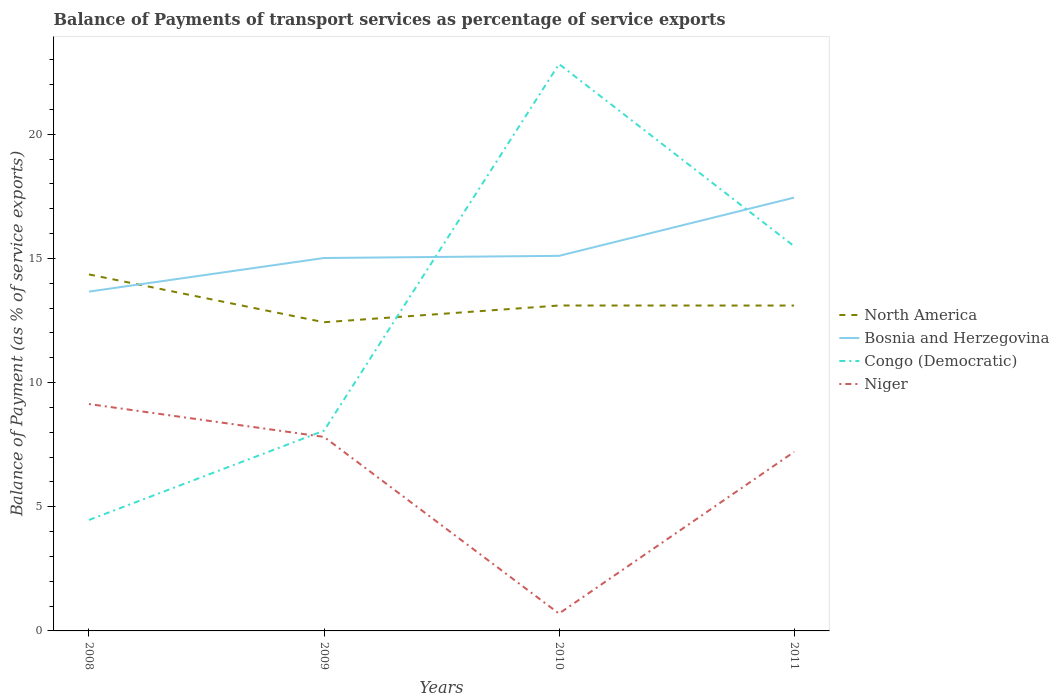How many different coloured lines are there?
Offer a terse response. 4. Does the line corresponding to Bosnia and Herzegovina intersect with the line corresponding to North America?
Your response must be concise. Yes. Is the number of lines equal to the number of legend labels?
Keep it short and to the point. Yes. Across all years, what is the maximum balance of payments of transport services in North America?
Your response must be concise. 12.43. In which year was the balance of payments of transport services in Congo (Democratic) maximum?
Offer a very short reply. 2008. What is the total balance of payments of transport services in North America in the graph?
Make the answer very short. -0.67. What is the difference between the highest and the second highest balance of payments of transport services in Congo (Democratic)?
Give a very brief answer. 18.36. What is the difference between the highest and the lowest balance of payments of transport services in North America?
Give a very brief answer. 1. Is the balance of payments of transport services in Bosnia and Herzegovina strictly greater than the balance of payments of transport services in North America over the years?
Give a very brief answer. No. Does the graph contain any zero values?
Provide a short and direct response. No. How many legend labels are there?
Keep it short and to the point. 4. How are the legend labels stacked?
Offer a very short reply. Vertical. What is the title of the graph?
Offer a terse response. Balance of Payments of transport services as percentage of service exports. Does "Comoros" appear as one of the legend labels in the graph?
Your response must be concise. No. What is the label or title of the X-axis?
Make the answer very short. Years. What is the label or title of the Y-axis?
Keep it short and to the point. Balance of Payment (as % of service exports). What is the Balance of Payment (as % of service exports) of North America in 2008?
Offer a terse response. 14.35. What is the Balance of Payment (as % of service exports) of Bosnia and Herzegovina in 2008?
Offer a terse response. 13.66. What is the Balance of Payment (as % of service exports) in Congo (Democratic) in 2008?
Provide a succinct answer. 4.47. What is the Balance of Payment (as % of service exports) of Niger in 2008?
Your response must be concise. 9.14. What is the Balance of Payment (as % of service exports) of North America in 2009?
Ensure brevity in your answer.  12.43. What is the Balance of Payment (as % of service exports) of Bosnia and Herzegovina in 2009?
Give a very brief answer. 15.02. What is the Balance of Payment (as % of service exports) of Congo (Democratic) in 2009?
Provide a short and direct response. 8.06. What is the Balance of Payment (as % of service exports) in Niger in 2009?
Ensure brevity in your answer.  7.81. What is the Balance of Payment (as % of service exports) in North America in 2010?
Your response must be concise. 13.1. What is the Balance of Payment (as % of service exports) of Bosnia and Herzegovina in 2010?
Your response must be concise. 15.1. What is the Balance of Payment (as % of service exports) of Congo (Democratic) in 2010?
Your answer should be compact. 22.83. What is the Balance of Payment (as % of service exports) of Niger in 2010?
Keep it short and to the point. 0.7. What is the Balance of Payment (as % of service exports) in North America in 2011?
Your response must be concise. 13.1. What is the Balance of Payment (as % of service exports) in Bosnia and Herzegovina in 2011?
Give a very brief answer. 17.45. What is the Balance of Payment (as % of service exports) in Congo (Democratic) in 2011?
Your answer should be compact. 15.49. What is the Balance of Payment (as % of service exports) of Niger in 2011?
Your response must be concise. 7.21. Across all years, what is the maximum Balance of Payment (as % of service exports) of North America?
Your answer should be very brief. 14.35. Across all years, what is the maximum Balance of Payment (as % of service exports) of Bosnia and Herzegovina?
Make the answer very short. 17.45. Across all years, what is the maximum Balance of Payment (as % of service exports) in Congo (Democratic)?
Offer a very short reply. 22.83. Across all years, what is the maximum Balance of Payment (as % of service exports) of Niger?
Your answer should be compact. 9.14. Across all years, what is the minimum Balance of Payment (as % of service exports) in North America?
Offer a terse response. 12.43. Across all years, what is the minimum Balance of Payment (as % of service exports) in Bosnia and Herzegovina?
Give a very brief answer. 13.66. Across all years, what is the minimum Balance of Payment (as % of service exports) of Congo (Democratic)?
Offer a terse response. 4.47. Across all years, what is the minimum Balance of Payment (as % of service exports) of Niger?
Offer a very short reply. 0.7. What is the total Balance of Payment (as % of service exports) in North America in the graph?
Your answer should be compact. 52.99. What is the total Balance of Payment (as % of service exports) in Bosnia and Herzegovina in the graph?
Keep it short and to the point. 61.23. What is the total Balance of Payment (as % of service exports) in Congo (Democratic) in the graph?
Ensure brevity in your answer.  50.85. What is the total Balance of Payment (as % of service exports) in Niger in the graph?
Your answer should be compact. 24.85. What is the difference between the Balance of Payment (as % of service exports) in North America in 2008 and that in 2009?
Offer a very short reply. 1.93. What is the difference between the Balance of Payment (as % of service exports) of Bosnia and Herzegovina in 2008 and that in 2009?
Your answer should be compact. -1.35. What is the difference between the Balance of Payment (as % of service exports) in Congo (Democratic) in 2008 and that in 2009?
Your answer should be very brief. -3.6. What is the difference between the Balance of Payment (as % of service exports) of Niger in 2008 and that in 2009?
Keep it short and to the point. 1.32. What is the difference between the Balance of Payment (as % of service exports) of North America in 2008 and that in 2010?
Offer a terse response. 1.25. What is the difference between the Balance of Payment (as % of service exports) of Bosnia and Herzegovina in 2008 and that in 2010?
Offer a terse response. -1.44. What is the difference between the Balance of Payment (as % of service exports) of Congo (Democratic) in 2008 and that in 2010?
Keep it short and to the point. -18.36. What is the difference between the Balance of Payment (as % of service exports) in Niger in 2008 and that in 2010?
Offer a very short reply. 8.44. What is the difference between the Balance of Payment (as % of service exports) of North America in 2008 and that in 2011?
Provide a short and direct response. 1.25. What is the difference between the Balance of Payment (as % of service exports) of Bosnia and Herzegovina in 2008 and that in 2011?
Offer a terse response. -3.78. What is the difference between the Balance of Payment (as % of service exports) in Congo (Democratic) in 2008 and that in 2011?
Offer a terse response. -11.02. What is the difference between the Balance of Payment (as % of service exports) of Niger in 2008 and that in 2011?
Keep it short and to the point. 1.93. What is the difference between the Balance of Payment (as % of service exports) in North America in 2009 and that in 2010?
Give a very brief answer. -0.67. What is the difference between the Balance of Payment (as % of service exports) in Bosnia and Herzegovina in 2009 and that in 2010?
Provide a succinct answer. -0.09. What is the difference between the Balance of Payment (as % of service exports) in Congo (Democratic) in 2009 and that in 2010?
Make the answer very short. -14.76. What is the difference between the Balance of Payment (as % of service exports) in Niger in 2009 and that in 2010?
Offer a very short reply. 7.11. What is the difference between the Balance of Payment (as % of service exports) of North America in 2009 and that in 2011?
Your answer should be very brief. -0.67. What is the difference between the Balance of Payment (as % of service exports) in Bosnia and Herzegovina in 2009 and that in 2011?
Offer a terse response. -2.43. What is the difference between the Balance of Payment (as % of service exports) of Congo (Democratic) in 2009 and that in 2011?
Keep it short and to the point. -7.43. What is the difference between the Balance of Payment (as % of service exports) of Niger in 2009 and that in 2011?
Your answer should be compact. 0.61. What is the difference between the Balance of Payment (as % of service exports) in North America in 2010 and that in 2011?
Offer a terse response. 0. What is the difference between the Balance of Payment (as % of service exports) of Bosnia and Herzegovina in 2010 and that in 2011?
Ensure brevity in your answer.  -2.34. What is the difference between the Balance of Payment (as % of service exports) in Congo (Democratic) in 2010 and that in 2011?
Your response must be concise. 7.33. What is the difference between the Balance of Payment (as % of service exports) in Niger in 2010 and that in 2011?
Give a very brief answer. -6.51. What is the difference between the Balance of Payment (as % of service exports) of North America in 2008 and the Balance of Payment (as % of service exports) of Bosnia and Herzegovina in 2009?
Make the answer very short. -0.66. What is the difference between the Balance of Payment (as % of service exports) of North America in 2008 and the Balance of Payment (as % of service exports) of Congo (Democratic) in 2009?
Your response must be concise. 6.29. What is the difference between the Balance of Payment (as % of service exports) of North America in 2008 and the Balance of Payment (as % of service exports) of Niger in 2009?
Offer a very short reply. 6.54. What is the difference between the Balance of Payment (as % of service exports) in Bosnia and Herzegovina in 2008 and the Balance of Payment (as % of service exports) in Congo (Democratic) in 2009?
Give a very brief answer. 5.6. What is the difference between the Balance of Payment (as % of service exports) of Bosnia and Herzegovina in 2008 and the Balance of Payment (as % of service exports) of Niger in 2009?
Offer a very short reply. 5.85. What is the difference between the Balance of Payment (as % of service exports) of Congo (Democratic) in 2008 and the Balance of Payment (as % of service exports) of Niger in 2009?
Offer a terse response. -3.34. What is the difference between the Balance of Payment (as % of service exports) of North America in 2008 and the Balance of Payment (as % of service exports) of Bosnia and Herzegovina in 2010?
Offer a very short reply. -0.75. What is the difference between the Balance of Payment (as % of service exports) in North America in 2008 and the Balance of Payment (as % of service exports) in Congo (Democratic) in 2010?
Make the answer very short. -8.47. What is the difference between the Balance of Payment (as % of service exports) in North America in 2008 and the Balance of Payment (as % of service exports) in Niger in 2010?
Your response must be concise. 13.66. What is the difference between the Balance of Payment (as % of service exports) in Bosnia and Herzegovina in 2008 and the Balance of Payment (as % of service exports) in Congo (Democratic) in 2010?
Offer a terse response. -9.16. What is the difference between the Balance of Payment (as % of service exports) in Bosnia and Herzegovina in 2008 and the Balance of Payment (as % of service exports) in Niger in 2010?
Make the answer very short. 12.96. What is the difference between the Balance of Payment (as % of service exports) of Congo (Democratic) in 2008 and the Balance of Payment (as % of service exports) of Niger in 2010?
Your answer should be very brief. 3.77. What is the difference between the Balance of Payment (as % of service exports) of North America in 2008 and the Balance of Payment (as % of service exports) of Bosnia and Herzegovina in 2011?
Provide a short and direct response. -3.09. What is the difference between the Balance of Payment (as % of service exports) in North America in 2008 and the Balance of Payment (as % of service exports) in Congo (Democratic) in 2011?
Offer a terse response. -1.14. What is the difference between the Balance of Payment (as % of service exports) of North America in 2008 and the Balance of Payment (as % of service exports) of Niger in 2011?
Offer a very short reply. 7.15. What is the difference between the Balance of Payment (as % of service exports) in Bosnia and Herzegovina in 2008 and the Balance of Payment (as % of service exports) in Congo (Democratic) in 2011?
Give a very brief answer. -1.83. What is the difference between the Balance of Payment (as % of service exports) in Bosnia and Herzegovina in 2008 and the Balance of Payment (as % of service exports) in Niger in 2011?
Offer a terse response. 6.46. What is the difference between the Balance of Payment (as % of service exports) in Congo (Democratic) in 2008 and the Balance of Payment (as % of service exports) in Niger in 2011?
Offer a terse response. -2.74. What is the difference between the Balance of Payment (as % of service exports) in North America in 2009 and the Balance of Payment (as % of service exports) in Bosnia and Herzegovina in 2010?
Provide a succinct answer. -2.67. What is the difference between the Balance of Payment (as % of service exports) of North America in 2009 and the Balance of Payment (as % of service exports) of Congo (Democratic) in 2010?
Offer a very short reply. -10.4. What is the difference between the Balance of Payment (as % of service exports) of North America in 2009 and the Balance of Payment (as % of service exports) of Niger in 2010?
Ensure brevity in your answer.  11.73. What is the difference between the Balance of Payment (as % of service exports) of Bosnia and Herzegovina in 2009 and the Balance of Payment (as % of service exports) of Congo (Democratic) in 2010?
Your response must be concise. -7.81. What is the difference between the Balance of Payment (as % of service exports) of Bosnia and Herzegovina in 2009 and the Balance of Payment (as % of service exports) of Niger in 2010?
Keep it short and to the point. 14.32. What is the difference between the Balance of Payment (as % of service exports) in Congo (Democratic) in 2009 and the Balance of Payment (as % of service exports) in Niger in 2010?
Make the answer very short. 7.36. What is the difference between the Balance of Payment (as % of service exports) in North America in 2009 and the Balance of Payment (as % of service exports) in Bosnia and Herzegovina in 2011?
Your answer should be compact. -5.02. What is the difference between the Balance of Payment (as % of service exports) in North America in 2009 and the Balance of Payment (as % of service exports) in Congo (Democratic) in 2011?
Provide a short and direct response. -3.06. What is the difference between the Balance of Payment (as % of service exports) of North America in 2009 and the Balance of Payment (as % of service exports) of Niger in 2011?
Provide a succinct answer. 5.22. What is the difference between the Balance of Payment (as % of service exports) in Bosnia and Herzegovina in 2009 and the Balance of Payment (as % of service exports) in Congo (Democratic) in 2011?
Offer a very short reply. -0.48. What is the difference between the Balance of Payment (as % of service exports) in Bosnia and Herzegovina in 2009 and the Balance of Payment (as % of service exports) in Niger in 2011?
Make the answer very short. 7.81. What is the difference between the Balance of Payment (as % of service exports) of Congo (Democratic) in 2009 and the Balance of Payment (as % of service exports) of Niger in 2011?
Ensure brevity in your answer.  0.86. What is the difference between the Balance of Payment (as % of service exports) in North America in 2010 and the Balance of Payment (as % of service exports) in Bosnia and Herzegovina in 2011?
Provide a short and direct response. -4.34. What is the difference between the Balance of Payment (as % of service exports) in North America in 2010 and the Balance of Payment (as % of service exports) in Congo (Democratic) in 2011?
Offer a terse response. -2.39. What is the difference between the Balance of Payment (as % of service exports) of North America in 2010 and the Balance of Payment (as % of service exports) of Niger in 2011?
Make the answer very short. 5.9. What is the difference between the Balance of Payment (as % of service exports) in Bosnia and Herzegovina in 2010 and the Balance of Payment (as % of service exports) in Congo (Democratic) in 2011?
Ensure brevity in your answer.  -0.39. What is the difference between the Balance of Payment (as % of service exports) of Bosnia and Herzegovina in 2010 and the Balance of Payment (as % of service exports) of Niger in 2011?
Your answer should be very brief. 7.9. What is the difference between the Balance of Payment (as % of service exports) of Congo (Democratic) in 2010 and the Balance of Payment (as % of service exports) of Niger in 2011?
Your answer should be very brief. 15.62. What is the average Balance of Payment (as % of service exports) in North America per year?
Offer a terse response. 13.25. What is the average Balance of Payment (as % of service exports) of Bosnia and Herzegovina per year?
Ensure brevity in your answer.  15.31. What is the average Balance of Payment (as % of service exports) of Congo (Democratic) per year?
Offer a very short reply. 12.71. What is the average Balance of Payment (as % of service exports) in Niger per year?
Ensure brevity in your answer.  6.21. In the year 2008, what is the difference between the Balance of Payment (as % of service exports) of North America and Balance of Payment (as % of service exports) of Bosnia and Herzegovina?
Provide a short and direct response. 0.69. In the year 2008, what is the difference between the Balance of Payment (as % of service exports) of North America and Balance of Payment (as % of service exports) of Congo (Democratic)?
Your answer should be very brief. 9.89. In the year 2008, what is the difference between the Balance of Payment (as % of service exports) of North America and Balance of Payment (as % of service exports) of Niger?
Keep it short and to the point. 5.22. In the year 2008, what is the difference between the Balance of Payment (as % of service exports) of Bosnia and Herzegovina and Balance of Payment (as % of service exports) of Congo (Democratic)?
Offer a very short reply. 9.2. In the year 2008, what is the difference between the Balance of Payment (as % of service exports) of Bosnia and Herzegovina and Balance of Payment (as % of service exports) of Niger?
Your answer should be very brief. 4.53. In the year 2008, what is the difference between the Balance of Payment (as % of service exports) in Congo (Democratic) and Balance of Payment (as % of service exports) in Niger?
Offer a terse response. -4.67. In the year 2009, what is the difference between the Balance of Payment (as % of service exports) of North America and Balance of Payment (as % of service exports) of Bosnia and Herzegovina?
Provide a succinct answer. -2.59. In the year 2009, what is the difference between the Balance of Payment (as % of service exports) of North America and Balance of Payment (as % of service exports) of Congo (Democratic)?
Your answer should be compact. 4.37. In the year 2009, what is the difference between the Balance of Payment (as % of service exports) in North America and Balance of Payment (as % of service exports) in Niger?
Keep it short and to the point. 4.62. In the year 2009, what is the difference between the Balance of Payment (as % of service exports) of Bosnia and Herzegovina and Balance of Payment (as % of service exports) of Congo (Democratic)?
Your response must be concise. 6.95. In the year 2009, what is the difference between the Balance of Payment (as % of service exports) in Bosnia and Herzegovina and Balance of Payment (as % of service exports) in Niger?
Provide a succinct answer. 7.2. In the year 2009, what is the difference between the Balance of Payment (as % of service exports) in Congo (Democratic) and Balance of Payment (as % of service exports) in Niger?
Your answer should be very brief. 0.25. In the year 2010, what is the difference between the Balance of Payment (as % of service exports) of North America and Balance of Payment (as % of service exports) of Bosnia and Herzegovina?
Provide a succinct answer. -2. In the year 2010, what is the difference between the Balance of Payment (as % of service exports) in North America and Balance of Payment (as % of service exports) in Congo (Democratic)?
Make the answer very short. -9.72. In the year 2010, what is the difference between the Balance of Payment (as % of service exports) of North America and Balance of Payment (as % of service exports) of Niger?
Keep it short and to the point. 12.4. In the year 2010, what is the difference between the Balance of Payment (as % of service exports) of Bosnia and Herzegovina and Balance of Payment (as % of service exports) of Congo (Democratic)?
Provide a short and direct response. -7.72. In the year 2010, what is the difference between the Balance of Payment (as % of service exports) in Bosnia and Herzegovina and Balance of Payment (as % of service exports) in Niger?
Give a very brief answer. 14.4. In the year 2010, what is the difference between the Balance of Payment (as % of service exports) of Congo (Democratic) and Balance of Payment (as % of service exports) of Niger?
Offer a terse response. 22.13. In the year 2011, what is the difference between the Balance of Payment (as % of service exports) in North America and Balance of Payment (as % of service exports) in Bosnia and Herzegovina?
Make the answer very short. -4.35. In the year 2011, what is the difference between the Balance of Payment (as % of service exports) in North America and Balance of Payment (as % of service exports) in Congo (Democratic)?
Provide a succinct answer. -2.39. In the year 2011, what is the difference between the Balance of Payment (as % of service exports) of North America and Balance of Payment (as % of service exports) of Niger?
Give a very brief answer. 5.89. In the year 2011, what is the difference between the Balance of Payment (as % of service exports) of Bosnia and Herzegovina and Balance of Payment (as % of service exports) of Congo (Democratic)?
Make the answer very short. 1.96. In the year 2011, what is the difference between the Balance of Payment (as % of service exports) in Bosnia and Herzegovina and Balance of Payment (as % of service exports) in Niger?
Offer a very short reply. 10.24. In the year 2011, what is the difference between the Balance of Payment (as % of service exports) in Congo (Democratic) and Balance of Payment (as % of service exports) in Niger?
Offer a very short reply. 8.29. What is the ratio of the Balance of Payment (as % of service exports) of North America in 2008 to that in 2009?
Offer a very short reply. 1.15. What is the ratio of the Balance of Payment (as % of service exports) in Bosnia and Herzegovina in 2008 to that in 2009?
Provide a short and direct response. 0.91. What is the ratio of the Balance of Payment (as % of service exports) in Congo (Democratic) in 2008 to that in 2009?
Ensure brevity in your answer.  0.55. What is the ratio of the Balance of Payment (as % of service exports) in Niger in 2008 to that in 2009?
Give a very brief answer. 1.17. What is the ratio of the Balance of Payment (as % of service exports) of North America in 2008 to that in 2010?
Offer a very short reply. 1.1. What is the ratio of the Balance of Payment (as % of service exports) of Bosnia and Herzegovina in 2008 to that in 2010?
Provide a short and direct response. 0.9. What is the ratio of the Balance of Payment (as % of service exports) of Congo (Democratic) in 2008 to that in 2010?
Ensure brevity in your answer.  0.2. What is the ratio of the Balance of Payment (as % of service exports) in Niger in 2008 to that in 2010?
Offer a very short reply. 13.07. What is the ratio of the Balance of Payment (as % of service exports) in North America in 2008 to that in 2011?
Your answer should be very brief. 1.1. What is the ratio of the Balance of Payment (as % of service exports) in Bosnia and Herzegovina in 2008 to that in 2011?
Offer a very short reply. 0.78. What is the ratio of the Balance of Payment (as % of service exports) of Congo (Democratic) in 2008 to that in 2011?
Your response must be concise. 0.29. What is the ratio of the Balance of Payment (as % of service exports) in Niger in 2008 to that in 2011?
Your response must be concise. 1.27. What is the ratio of the Balance of Payment (as % of service exports) in North America in 2009 to that in 2010?
Provide a short and direct response. 0.95. What is the ratio of the Balance of Payment (as % of service exports) in Bosnia and Herzegovina in 2009 to that in 2010?
Ensure brevity in your answer.  0.99. What is the ratio of the Balance of Payment (as % of service exports) in Congo (Democratic) in 2009 to that in 2010?
Offer a terse response. 0.35. What is the ratio of the Balance of Payment (as % of service exports) in Niger in 2009 to that in 2010?
Offer a terse response. 11.18. What is the ratio of the Balance of Payment (as % of service exports) in North America in 2009 to that in 2011?
Your response must be concise. 0.95. What is the ratio of the Balance of Payment (as % of service exports) of Bosnia and Herzegovina in 2009 to that in 2011?
Your answer should be very brief. 0.86. What is the ratio of the Balance of Payment (as % of service exports) in Congo (Democratic) in 2009 to that in 2011?
Offer a terse response. 0.52. What is the ratio of the Balance of Payment (as % of service exports) of Niger in 2009 to that in 2011?
Keep it short and to the point. 1.08. What is the ratio of the Balance of Payment (as % of service exports) in Bosnia and Herzegovina in 2010 to that in 2011?
Your answer should be compact. 0.87. What is the ratio of the Balance of Payment (as % of service exports) of Congo (Democratic) in 2010 to that in 2011?
Your answer should be compact. 1.47. What is the ratio of the Balance of Payment (as % of service exports) of Niger in 2010 to that in 2011?
Give a very brief answer. 0.1. What is the difference between the highest and the second highest Balance of Payment (as % of service exports) in North America?
Give a very brief answer. 1.25. What is the difference between the highest and the second highest Balance of Payment (as % of service exports) of Bosnia and Herzegovina?
Offer a terse response. 2.34. What is the difference between the highest and the second highest Balance of Payment (as % of service exports) of Congo (Democratic)?
Your answer should be very brief. 7.33. What is the difference between the highest and the second highest Balance of Payment (as % of service exports) of Niger?
Offer a very short reply. 1.32. What is the difference between the highest and the lowest Balance of Payment (as % of service exports) in North America?
Your response must be concise. 1.93. What is the difference between the highest and the lowest Balance of Payment (as % of service exports) of Bosnia and Herzegovina?
Your response must be concise. 3.78. What is the difference between the highest and the lowest Balance of Payment (as % of service exports) of Congo (Democratic)?
Offer a terse response. 18.36. What is the difference between the highest and the lowest Balance of Payment (as % of service exports) of Niger?
Your answer should be compact. 8.44. 